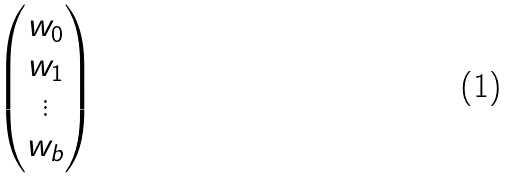<formula> <loc_0><loc_0><loc_500><loc_500>\begin{pmatrix} w _ { 0 } \\ w _ { 1 } \\ \vdots \\ w _ { b } \end{pmatrix}</formula> 